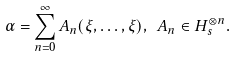Convert formula to latex. <formula><loc_0><loc_0><loc_500><loc_500>\alpha = \sum ^ { \infty } _ { n = 0 } A _ { n } ( \xi , \dots , \xi ) , \ A _ { n } \in H ^ { \otimes n } _ { s } .</formula> 